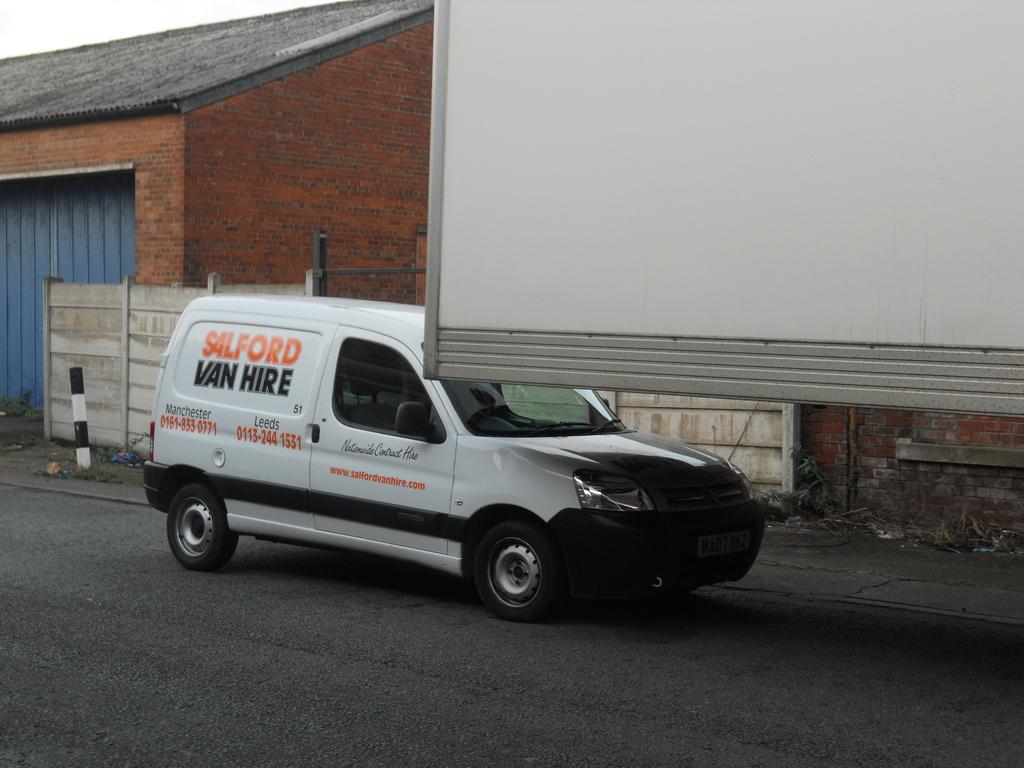<image>
Present a compact description of the photo's key features. A grey van with red letters that display "Salford" is parked on the side of the road. 